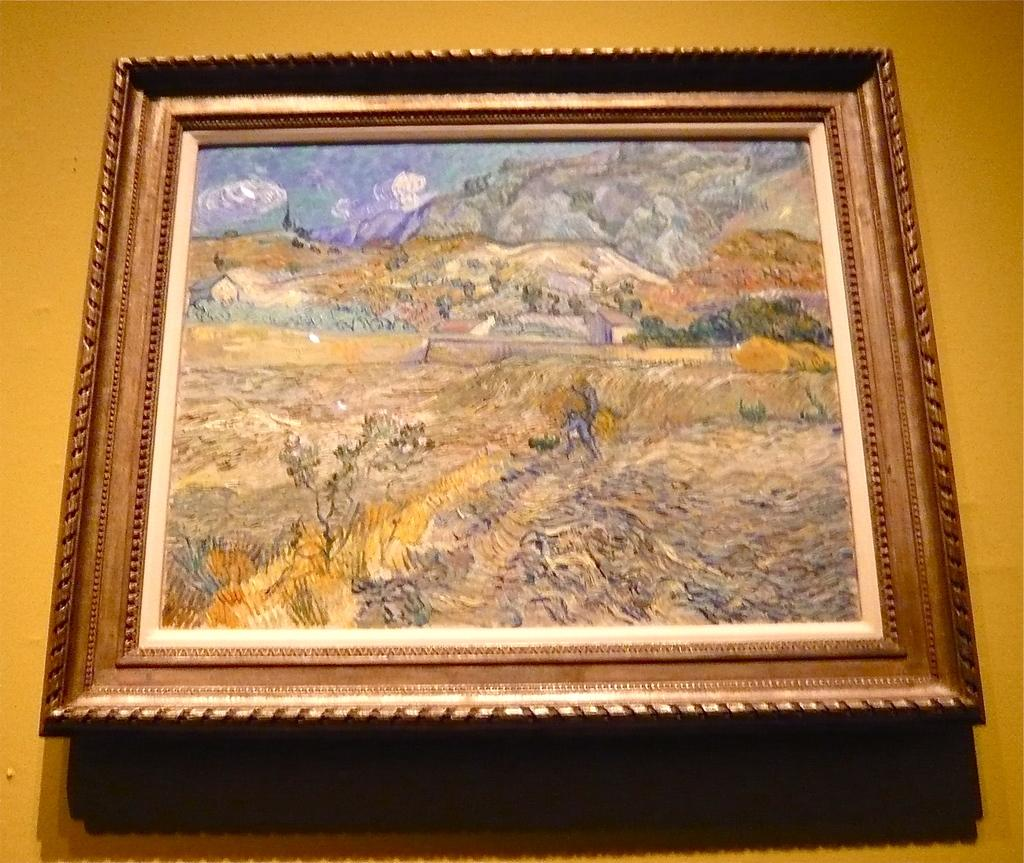What is attached to the wall in the image? There is a frame attached to the wall in the image. What is depicted within the frame? The frame contains an image of an animal. What else can be seen in the image besides the frame? The image contains few houses and trees are visible in the image. What color is the wall in the background? The wall in the background is yellow. What type of yarn is being used in the fight scene depicted in the image? There is no fight scene or yarn present in the image; it features a frame with an image of an animal and other elements. 